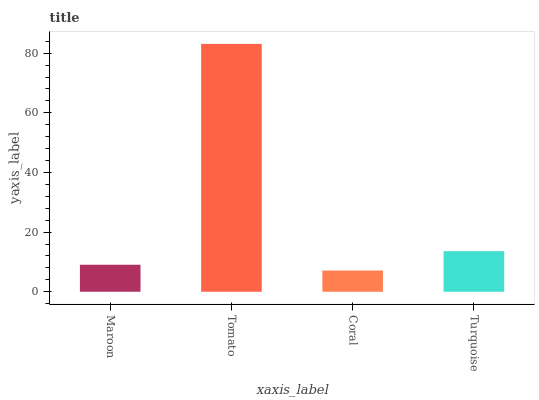Is Coral the minimum?
Answer yes or no. Yes. Is Tomato the maximum?
Answer yes or no. Yes. Is Tomato the minimum?
Answer yes or no. No. Is Coral the maximum?
Answer yes or no. No. Is Tomato greater than Coral?
Answer yes or no. Yes. Is Coral less than Tomato?
Answer yes or no. Yes. Is Coral greater than Tomato?
Answer yes or no. No. Is Tomato less than Coral?
Answer yes or no. No. Is Turquoise the high median?
Answer yes or no. Yes. Is Maroon the low median?
Answer yes or no. Yes. Is Tomato the high median?
Answer yes or no. No. Is Coral the low median?
Answer yes or no. No. 